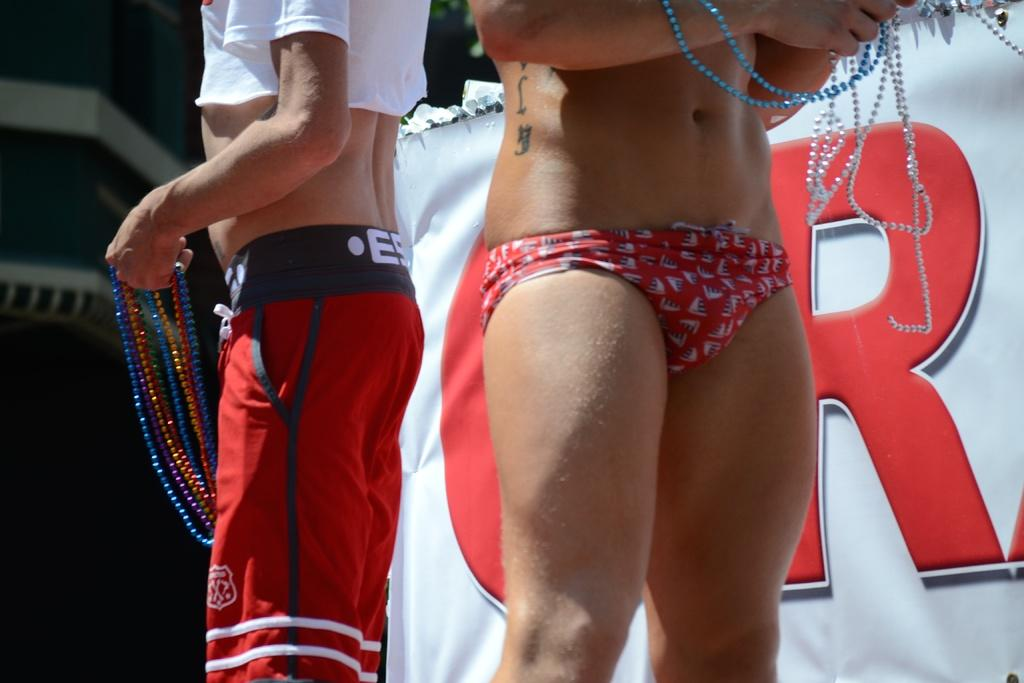<image>
Relay a brief, clear account of the picture shown. A man and a woman holding bead necklaces stand in front of a large red letter R. 